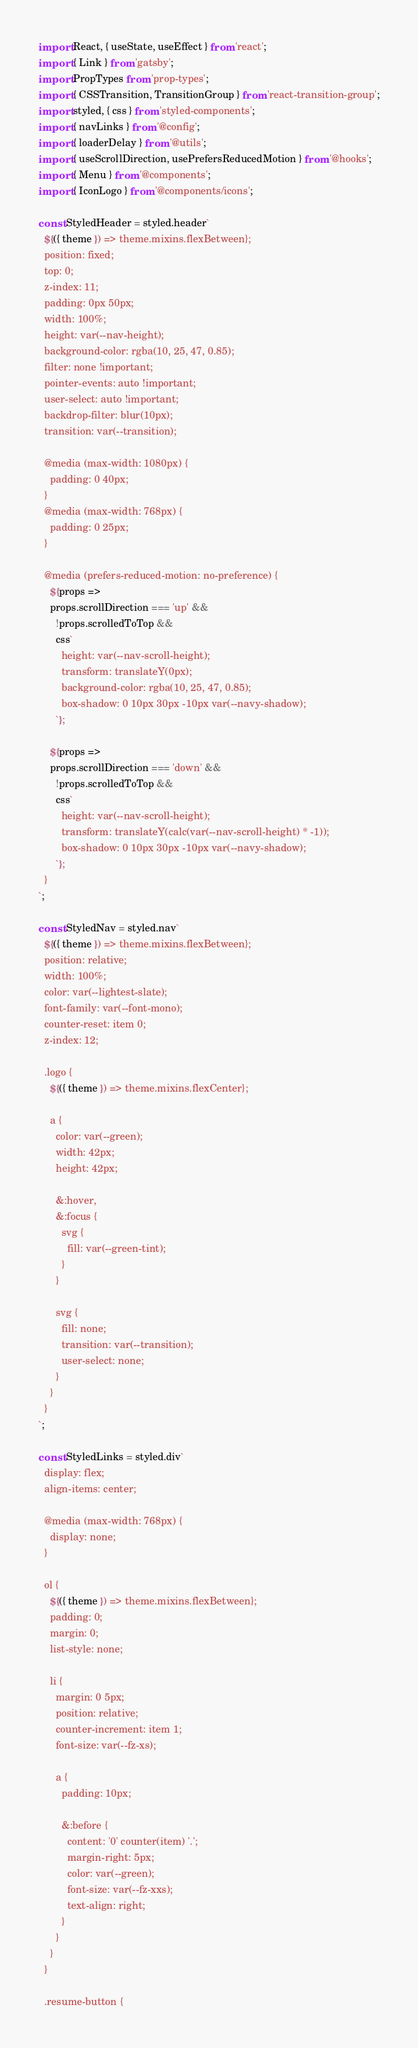<code> <loc_0><loc_0><loc_500><loc_500><_JavaScript_>import React, { useState, useEffect } from 'react';
import { Link } from 'gatsby';
import PropTypes from 'prop-types';
import { CSSTransition, TransitionGroup } from 'react-transition-group';
import styled, { css } from 'styled-components';
import { navLinks } from '@config';
import { loaderDelay } from '@utils';
import { useScrollDirection, usePrefersReducedMotion } from '@hooks';
import { Menu } from '@components';
import { IconLogo } from '@components/icons';

const StyledHeader = styled.header`
  ${({ theme }) => theme.mixins.flexBetween};
  position: fixed;
  top: 0;
  z-index: 11;
  padding: 0px 50px;
  width: 100%;
  height: var(--nav-height);
  background-color: rgba(10, 25, 47, 0.85);
  filter: none !important;
  pointer-events: auto !important;
  user-select: auto !important;
  backdrop-filter: blur(10px);
  transition: var(--transition);

  @media (max-width: 1080px) {
    padding: 0 40px;
  }
  @media (max-width: 768px) {
    padding: 0 25px;
  }

  @media (prefers-reduced-motion: no-preference) {
    ${props =>
    props.scrollDirection === 'up' &&
      !props.scrolledToTop &&
      css`
        height: var(--nav-scroll-height);
        transform: translateY(0px);
        background-color: rgba(10, 25, 47, 0.85);
        box-shadow: 0 10px 30px -10px var(--navy-shadow);
      `};

    ${props =>
    props.scrollDirection === 'down' &&
      !props.scrolledToTop &&
      css`
        height: var(--nav-scroll-height);
        transform: translateY(calc(var(--nav-scroll-height) * -1));
        box-shadow: 0 10px 30px -10px var(--navy-shadow);
      `};
  }
`;

const StyledNav = styled.nav`
  ${({ theme }) => theme.mixins.flexBetween};
  position: relative;
  width: 100%;
  color: var(--lightest-slate);
  font-family: var(--font-mono);
  counter-reset: item 0;
  z-index: 12;

  .logo {
    ${({ theme }) => theme.mixins.flexCenter};

    a {
      color: var(--green);
      width: 42px;
      height: 42px;

      &:hover,
      &:focus {
        svg {
          fill: var(--green-tint);
        }
      }

      svg {
        fill: none;
        transition: var(--transition);
        user-select: none;
      }
    }
  }
`;

const StyledLinks = styled.div`
  display: flex;
  align-items: center;

  @media (max-width: 768px) {
    display: none;
  }

  ol {
    ${({ theme }) => theme.mixins.flexBetween};
    padding: 0;
    margin: 0;
    list-style: none;

    li {
      margin: 0 5px;
      position: relative;
      counter-increment: item 1;
      font-size: var(--fz-xs);

      a {
        padding: 10px;

        &:before {
          content: '0' counter(item) '.';
          margin-right: 5px;
          color: var(--green);
          font-size: var(--fz-xxs);
          text-align: right;
        }
      }
    }
  }

  .resume-button {</code> 